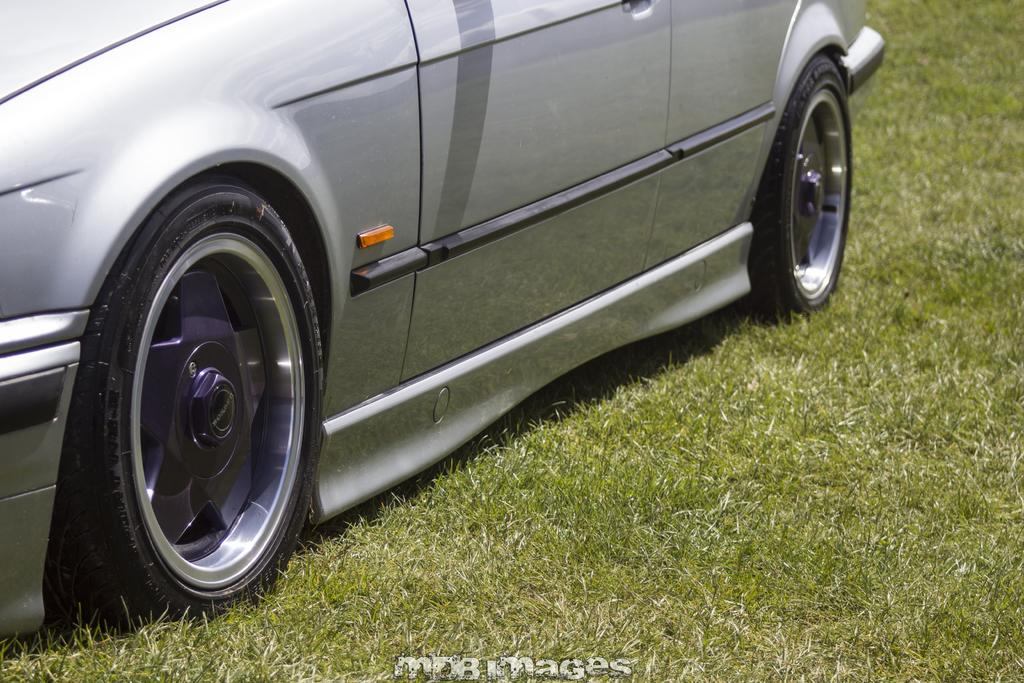What is the main subject of the image? The main subject of the image is a car. Where is the car located in the image? The car is on the grass in the image. What type of acoustics can be heard coming from the car in the image? There is no information about the car's acoustics in the image, so it cannot be determined. 